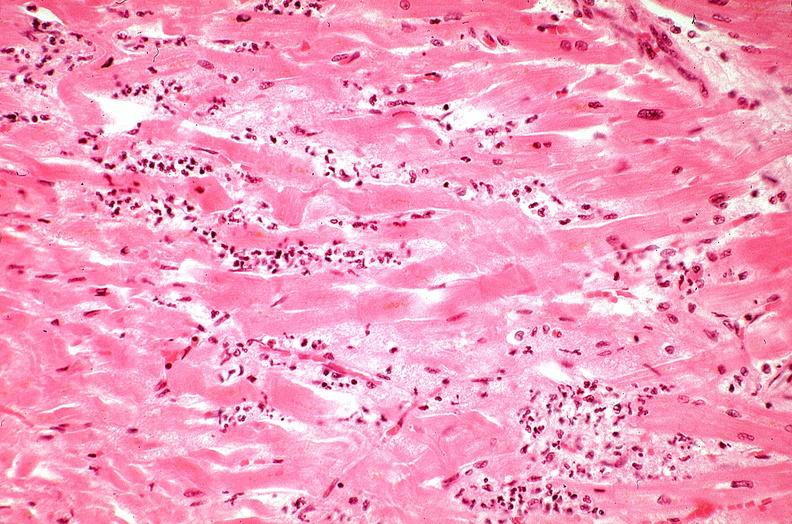does this image show heart, myocardial infarction, wavey fiber change, necrtosis, hemorrhage, and dissection?
Answer the question using a single word or phrase. Yes 